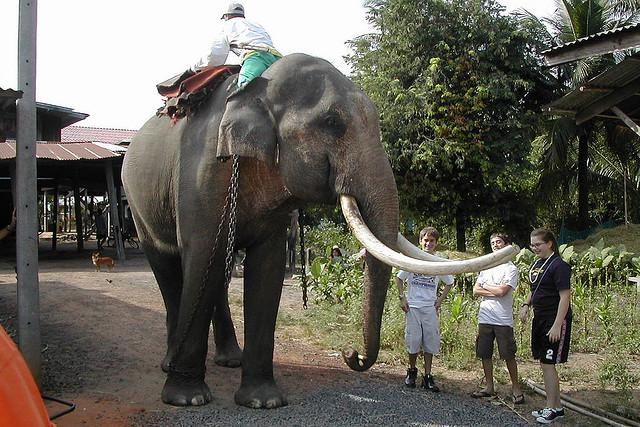Why is it unusual for elephants to have tusks this big? they break 